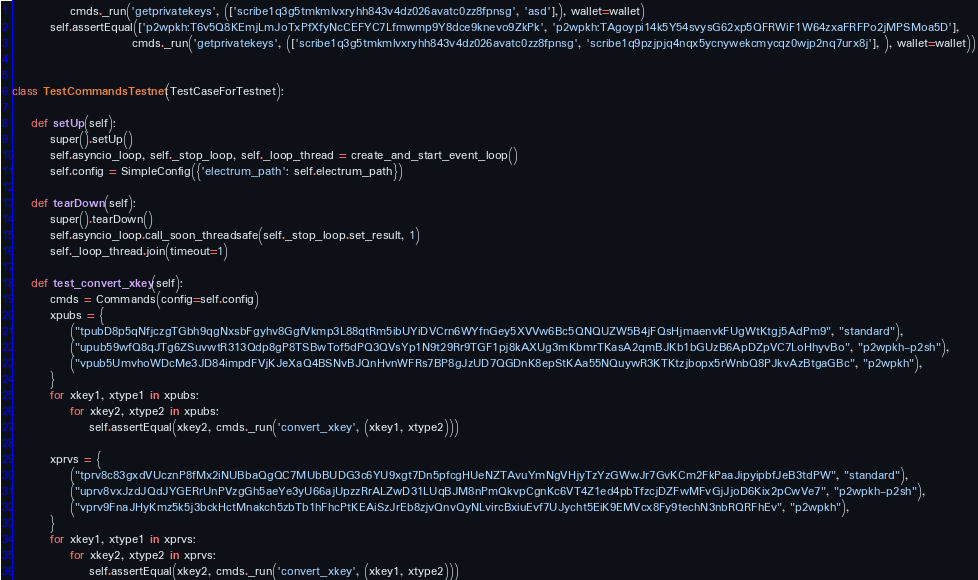<code> <loc_0><loc_0><loc_500><loc_500><_Python_>            cmds._run('getprivatekeys', (['scribe1q3g5tmkmlvxryhh843v4dz026avatc0zz8fpnsg', 'asd'],), wallet=wallet)
        self.assertEqual(['p2wpkh:T6v5Q8KEmjLmJoTxPfXfyNcCEFYC7Lfmwmp9Y8dce9knevo9ZkPk', 'p2wpkh:TAgoypi14k5Y54svysG62xp5QFRWiF1W64zxaFRFPo2jMPSMoa5D'],
                         cmds._run('getprivatekeys', (['scribe1q3g5tmkmlvxryhh843v4dz026avatc0zz8fpnsg', 'scribe1q9pzjpjq4nqx5ycnywekcmycqz0wjp2nq7urx8j'], ), wallet=wallet))


class TestCommandsTestnet(TestCaseForTestnet):

    def setUp(self):
        super().setUp()
        self.asyncio_loop, self._stop_loop, self._loop_thread = create_and_start_event_loop()
        self.config = SimpleConfig({'electrum_path': self.electrum_path})

    def tearDown(self):
        super().tearDown()
        self.asyncio_loop.call_soon_threadsafe(self._stop_loop.set_result, 1)
        self._loop_thread.join(timeout=1)

    def test_convert_xkey(self):
        cmds = Commands(config=self.config)
        xpubs = {
            ("tpubD8p5qNfjczgTGbh9qgNxsbFgyhv8GgfVkmp3L88qtRm5ibUYiDVCrn6WYfnGey5XVVw6Bc5QNQUZW5B4jFQsHjmaenvkFUgWtKtgj5AdPm9", "standard"),
            ("upub59wfQ8qJTg6ZSuvwtR313Qdp8gP8TSBwTof5dPQ3QVsYp1N9t29Rr9TGF1pj8kAXUg3mKbmrTKasA2qmBJKb1bGUzB6ApDZpVC7LoHhyvBo", "p2wpkh-p2sh"),
            ("vpub5UmvhoWDcMe3JD84impdFVjKJeXaQ4BSNvBJQnHvnWFRs7BP8gJzUD7QGDnK8epStKAa55NQuywR3KTKtzjbopx5rWnbQ8PJkvAzBtgaGBc", "p2wpkh"),
        }
        for xkey1, xtype1 in xpubs:
            for xkey2, xtype2 in xpubs:
                self.assertEqual(xkey2, cmds._run('convert_xkey', (xkey1, xtype2)))

        xprvs = {
            ("tprv8c83gxdVUcznP8fMx2iNUBbaQgQC7MUbBUDG3c6YU9xgt7Dn5pfcgHUeNZTAvuYmNgVHjyTzYzGWwJr7GvKCm2FkPaaJipyipbfJeB3tdPW", "standard"),
            ("uprv8vxJzdJQdJYGERrUnPVzgGh5aeYe3yU66ajUpzzRrALZwD31LUqBJM8nPmQkvpCgnKc6VT4Z1ed4pbTfzcjDZFwMFvGjJjoD6Kix2pCwVe7", "p2wpkh-p2sh"),
            ("vprv9FnaJHyKmz5k5j3bckHctMnakch5zbTb1hFhcPtKEAiSzJrEb8zjvQnvQyNLvircBxiuEvf7UJycht5EiK9EMVcx8Fy9techN3nbRQRFhEv", "p2wpkh"),
        }
        for xkey1, xtype1 in xprvs:
            for xkey2, xtype2 in xprvs:
                self.assertEqual(xkey2, cmds._run('convert_xkey', (xkey1, xtype2)))
</code> 